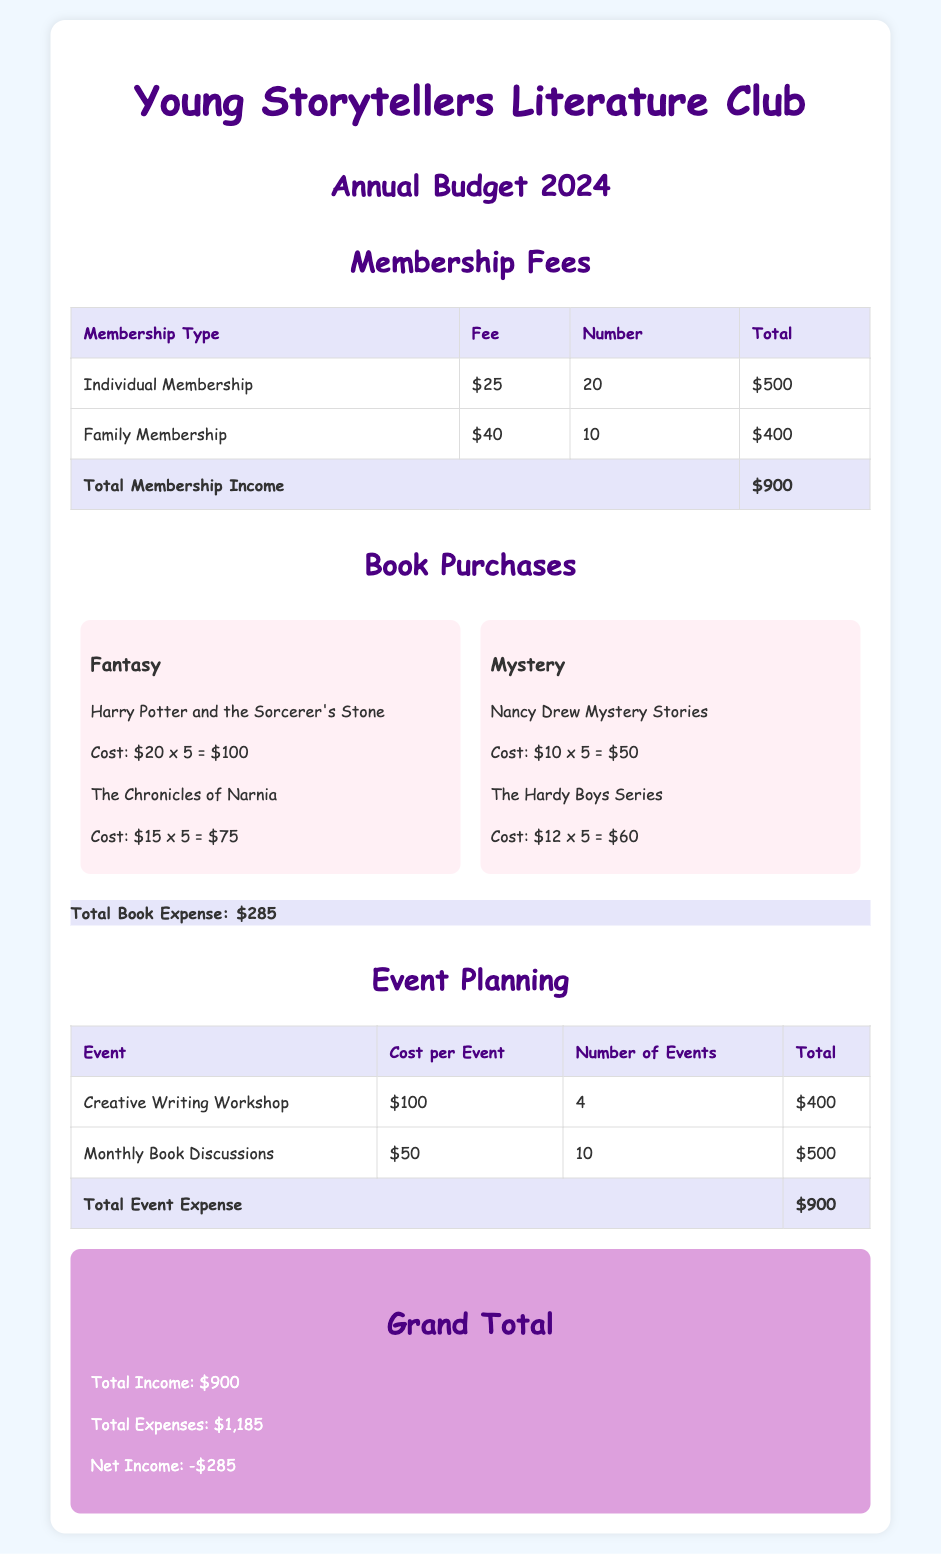What is the membership fee for Individual Membership? The document states that the fee for Individual Membership is $25.
Answer: $25 How many Family Memberships are there? The table shows that there are 10 Family Memberships.
Answer: 10 What is the total expense for book purchases? The total expense for book purchases is listed as $285.
Answer: $285 How many Creative Writing Workshops are planned? The document indicates that there are 4 Creative Writing Workshops planned.
Answer: 4 What is the total income from membership fees? The total income from membership fees is calculated as $900 in the document.
Answer: $900 What is the net income for the club? The document shows that the net income is -$285.
Answer: -$285 What is the cost of the Hardy Boys Series? The document states that the cost of the Hardy Boys Series is $12 per book, with 5 books purchased, totaling $60.
Answer: $60 What is the total number of events planned? By adding all the events from the document, there are 14 events planned.
Answer: 14 How much is allocated for Monthly Book Discussions? The total cost allocated for Monthly Book Discussions is stated as $500.
Answer: $500 